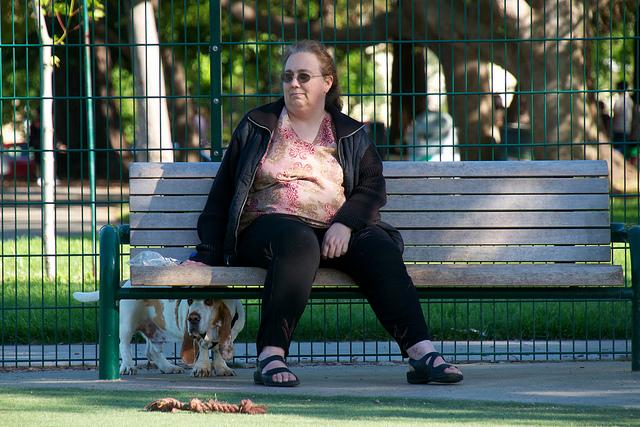What dog breed does the woman have? bassett hound 